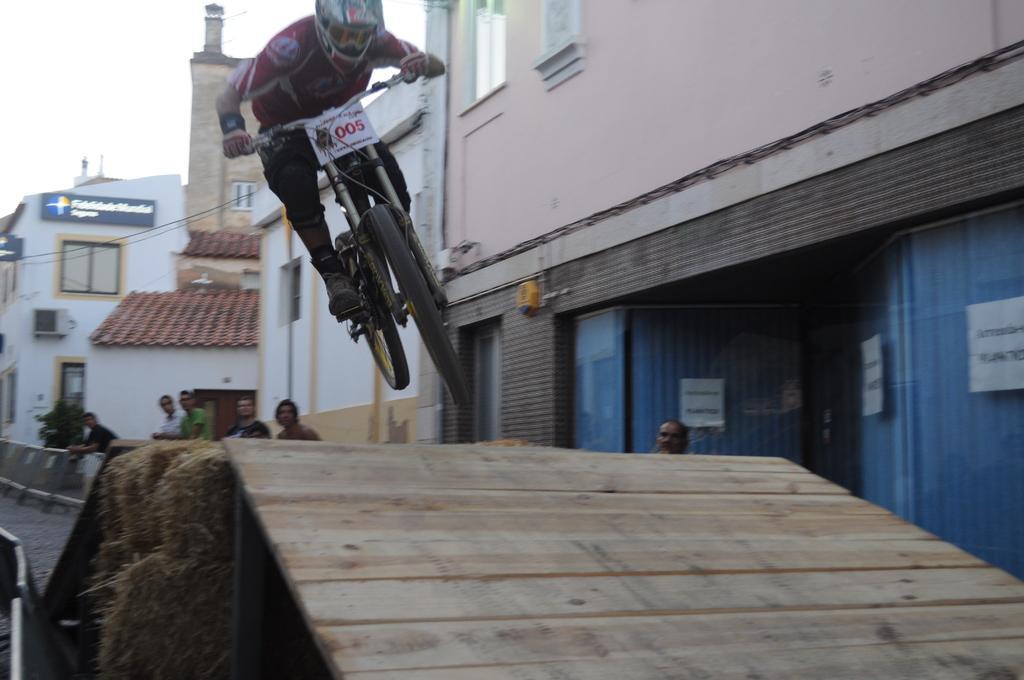In one or two sentences, can you explain what this image depicts? At the bottom of the image, we can see wooden platform and grass rolls. In the foreground, we can see a person and a vehicle. In the background, we can see buildings, barriers, plants, boards and people. At the top of the image, we can see the sky. 